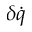<formula> <loc_0><loc_0><loc_500><loc_500>\delta \dot { q }</formula> 